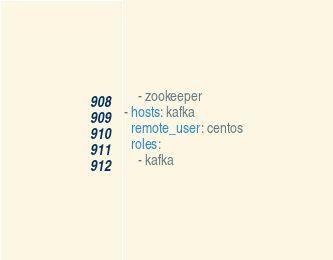Convert code to text. <code><loc_0><loc_0><loc_500><loc_500><_YAML_>    - zookeeper
- hosts: kafka
  remote_user: centos
  roles:
    - kafka
</code> 